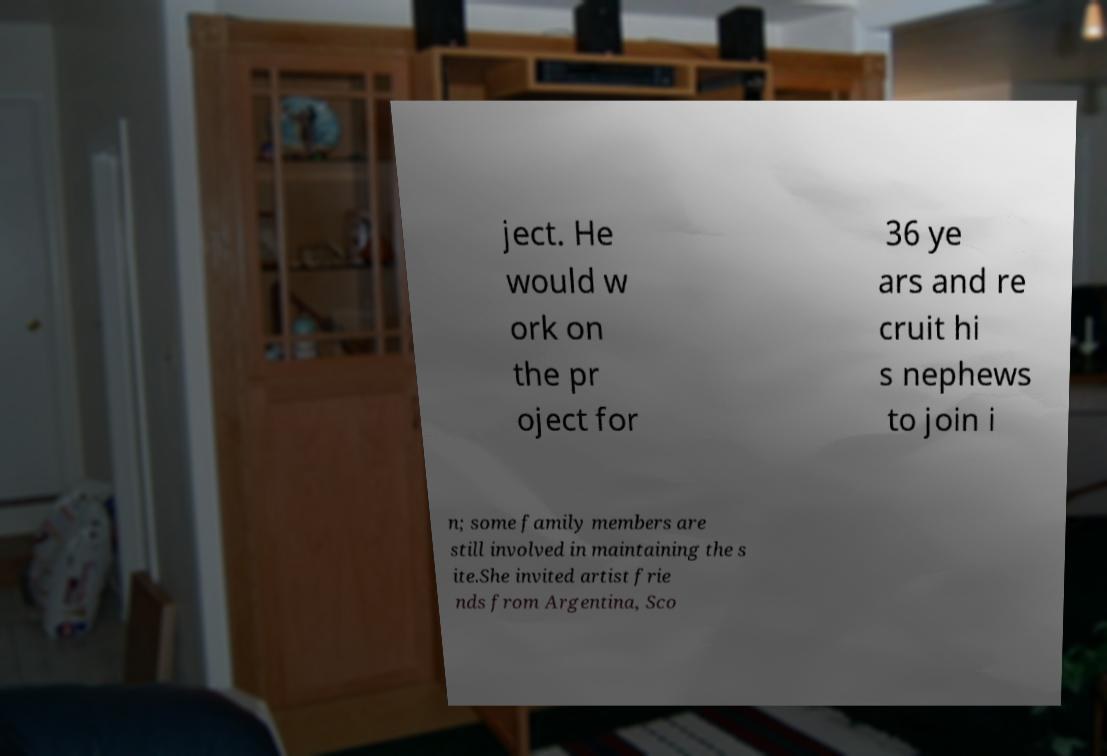Could you extract and type out the text from this image? ject. He would w ork on the pr oject for 36 ye ars and re cruit hi s nephews to join i n; some family members are still involved in maintaining the s ite.She invited artist frie nds from Argentina, Sco 